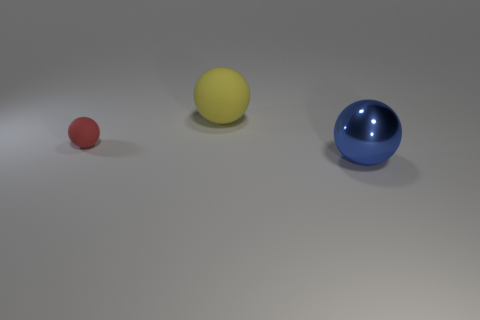Add 2 big yellow things. How many objects exist? 5 Subtract all big yellow rubber things. Subtract all metal things. How many objects are left? 1 Add 1 spheres. How many spheres are left? 4 Add 1 small blue objects. How many small blue objects exist? 1 Subtract 0 gray blocks. How many objects are left? 3 